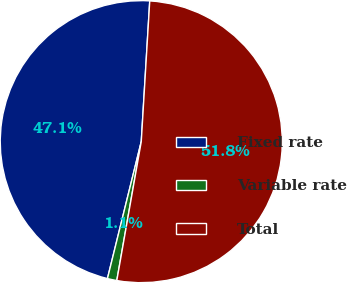Convert chart to OTSL. <chart><loc_0><loc_0><loc_500><loc_500><pie_chart><fcel>Fixed rate<fcel>Variable rate<fcel>Total<nl><fcel>47.11%<fcel>1.08%<fcel>51.82%<nl></chart> 